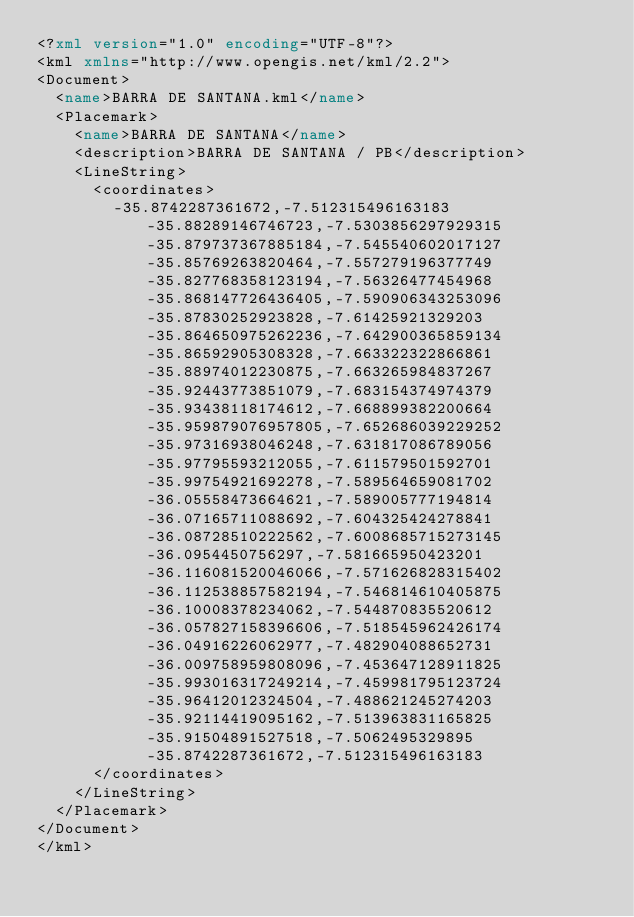Convert code to text. <code><loc_0><loc_0><loc_500><loc_500><_XML_><?xml version="1.0" encoding="UTF-8"?>
<kml xmlns="http://www.opengis.net/kml/2.2">
<Document>
	<name>BARRA DE SANTANA.kml</name>
	<Placemark>
		<name>BARRA DE SANTANA</name>
		<description>BARRA DE SANTANA / PB</description>
		<LineString>
			<coordinates>
				-35.8742287361672,-7.512315496163183 -35.88289146746723,-7.5303856297929315 -35.879737367885184,-7.545540602017127 -35.85769263820464,-7.557279196377749 -35.827768358123194,-7.56326477454968 -35.868147726436405,-7.590906343253096 -35.87830252923828,-7.61425921329203 -35.864650975262236,-7.642900365859134 -35.86592905308328,-7.663322322866861 -35.88974012230875,-7.663265984837267 -35.92443773851079,-7.683154374974379 -35.93438118174612,-7.668899382200664 -35.959879076957805,-7.652686039229252 -35.97316938046248,-7.631817086789056 -35.97795593212055,-7.611579501592701 -35.99754921692278,-7.589564659081702 -36.05558473664621,-7.589005777194814 -36.07165711088692,-7.604325424278841 -36.08728510222562,-7.6008685715273145 -36.0954450756297,-7.581665950423201 -36.116081520046066,-7.571626828315402 -36.112538857582194,-7.546814610405875 -36.10008378234062,-7.544870835520612 -36.057827158396606,-7.518545962426174 -36.04916226062977,-7.482904088652731 -36.009758959808096,-7.453647128911825 -35.993016317249214,-7.459981795123724 -35.96412012324504,-7.488621245274203 -35.92114419095162,-7.513963831165825 -35.91504891527518,-7.5062495329895 -35.8742287361672,-7.512315496163183
			</coordinates>
		</LineString>
	</Placemark>
</Document>
</kml></code> 